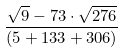<formula> <loc_0><loc_0><loc_500><loc_500>\frac { \sqrt { 9 } - 7 3 \cdot \sqrt { 2 7 6 } } { ( 5 + 1 3 3 + 3 0 6 ) }</formula> 